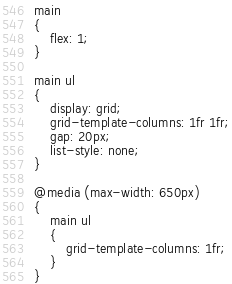<code> <loc_0><loc_0><loc_500><loc_500><_CSS_>main
{
    flex: 1;
}

main ul
{
    display: grid;
    grid-template-columns: 1fr 1fr;
    gap: 20px;
    list-style: none;
}

@media (max-width: 650px)
{
    main ul
    {
        grid-template-columns: 1fr;
    }
}
</code> 